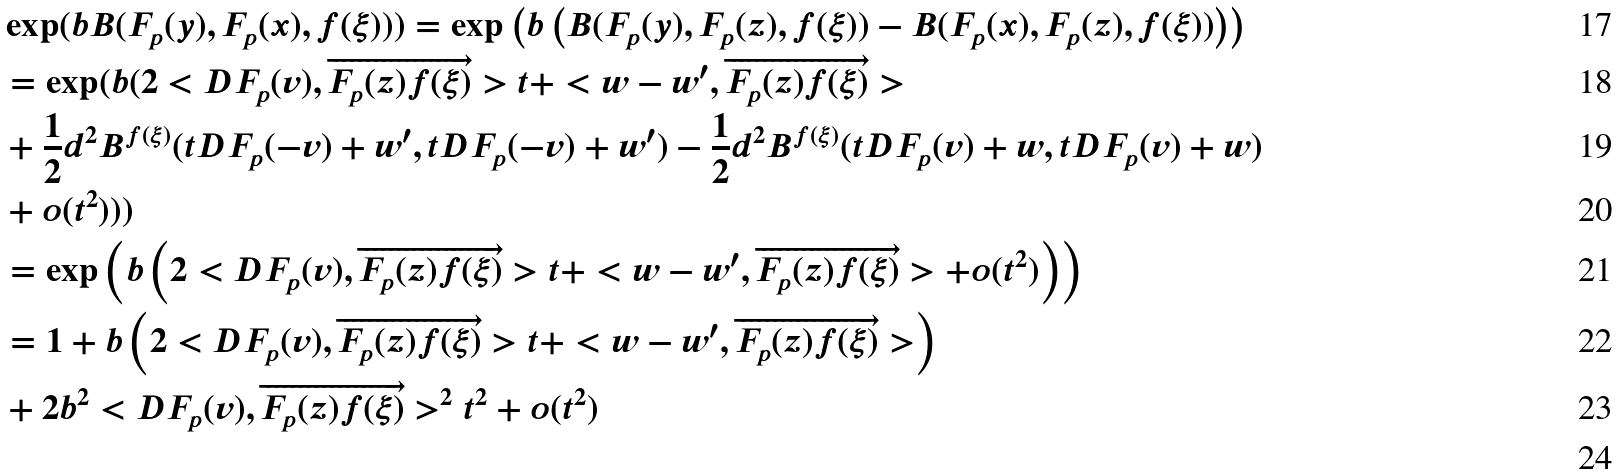<formula> <loc_0><loc_0><loc_500><loc_500>& \exp ( b B ( F _ { p } ( y ) , F _ { p } ( x ) , f ( \xi ) ) ) = \exp \left ( b \left ( B ( F _ { p } ( y ) , F _ { p } ( z ) , f ( \xi ) ) - B ( F _ { p } ( x ) , F _ { p } ( z ) , f ( \xi ) ) \right ) \right ) \\ & = \exp ( b ( 2 < D F _ { p } ( v ) , \overrightarrow { F _ { p } ( z ) f ( \xi ) } > t + < w - w ^ { \prime } , \overrightarrow { F _ { p } ( z ) f ( \xi ) } > \\ & + \frac { 1 } { 2 } d ^ { 2 } B ^ { f ( \xi ) } ( t D F _ { p } ( - v ) + w ^ { \prime } , t D F _ { p } ( - v ) + w ^ { \prime } ) - \frac { 1 } { 2 } d ^ { 2 } B ^ { f ( \xi ) } ( t D F _ { p } ( v ) + w , t D F _ { p } ( v ) + w ) \\ & + o ( t ^ { 2 } ) ) ) \\ & = \exp \left ( b \left ( 2 < D F _ { p } ( v ) , \overrightarrow { F _ { p } ( z ) f ( \xi ) } > t + < w - w ^ { \prime } , \overrightarrow { F _ { p } ( z ) f ( \xi ) } > + o ( t ^ { 2 } ) \right ) \right ) \\ & = 1 + b \left ( 2 < D F _ { p } ( v ) , \overrightarrow { F _ { p } ( z ) f ( \xi ) } > t + < w - w ^ { \prime } , \overrightarrow { F _ { p } ( z ) f ( \xi ) } > \right ) \\ & + 2 b ^ { 2 } < D F _ { p } ( v ) , \overrightarrow { F _ { p } ( z ) f ( \xi ) } > ^ { 2 } t ^ { 2 } + o ( t ^ { 2 } ) \\</formula> 